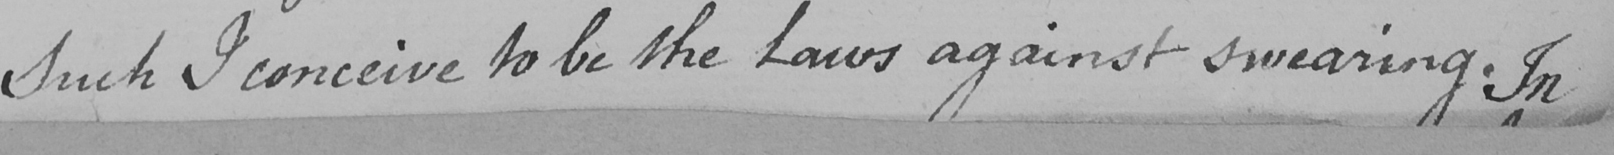What text is written in this handwritten line? Such I conceive to be the Laws against swearing . In 